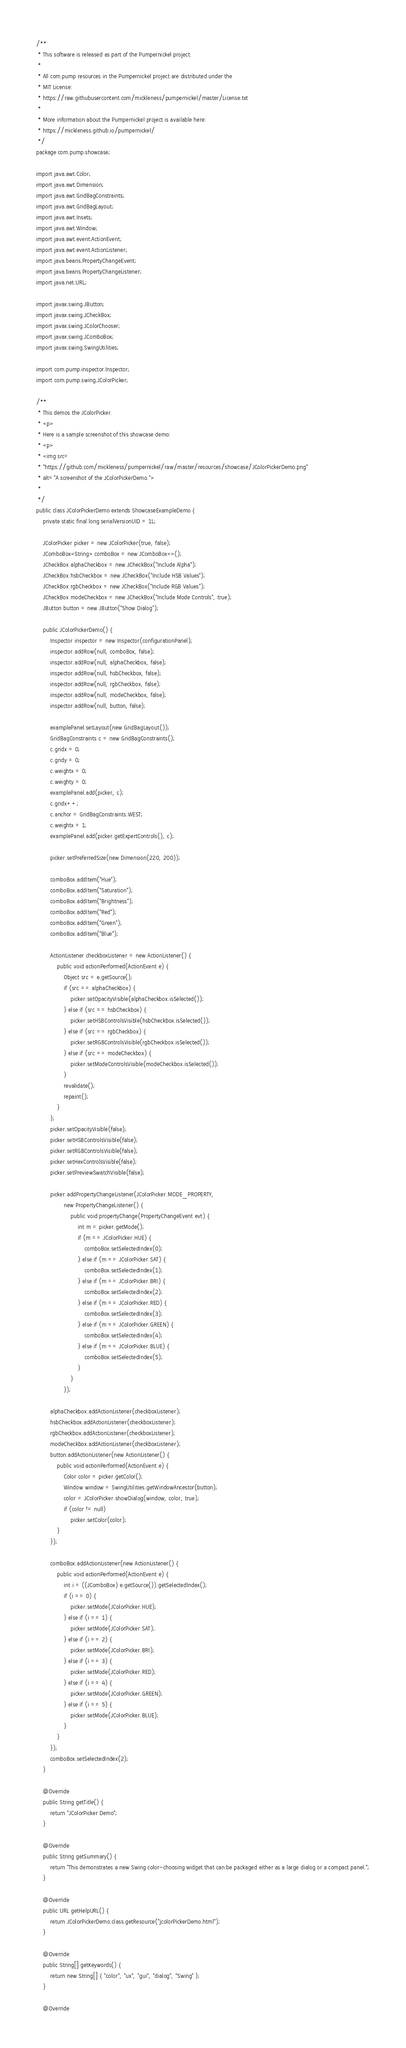Convert code to text. <code><loc_0><loc_0><loc_500><loc_500><_Java_>/**
 * This software is released as part of the Pumpernickel project.
 * 
 * All com.pump resources in the Pumpernickel project are distributed under the
 * MIT License:
 * https://raw.githubusercontent.com/mickleness/pumpernickel/master/License.txt
 * 
 * More information about the Pumpernickel project is available here:
 * https://mickleness.github.io/pumpernickel/
 */
package com.pump.showcase;

import java.awt.Color;
import java.awt.Dimension;
import java.awt.GridBagConstraints;
import java.awt.GridBagLayout;
import java.awt.Insets;
import java.awt.Window;
import java.awt.event.ActionEvent;
import java.awt.event.ActionListener;
import java.beans.PropertyChangeEvent;
import java.beans.PropertyChangeListener;
import java.net.URL;

import javax.swing.JButton;
import javax.swing.JCheckBox;
import javax.swing.JColorChooser;
import javax.swing.JComboBox;
import javax.swing.SwingUtilities;

import com.pump.inspector.Inspector;
import com.pump.swing.JColorPicker;

/**
 * This demos the JColorPicker.
 * <p>
 * Here is a sample screenshot of this showcase demo:
 * <p>
 * <img src=
 * "https://github.com/mickleness/pumpernickel/raw/master/resources/showcase/JColorPickerDemo.png"
 * alt="A screenshot of the JColorPickerDemo.">
 *
 */
public class JColorPickerDemo extends ShowcaseExampleDemo {
	private static final long serialVersionUID = 1L;

	JColorPicker picker = new JColorPicker(true, false);
	JComboBox<String> comboBox = new JComboBox<>();
	JCheckBox alphaCheckbox = new JCheckBox("Include Alpha");
	JCheckBox hsbCheckbox = new JCheckBox("Include HSB Values");
	JCheckBox rgbCheckbox = new JCheckBox("Include RGB Values");
	JCheckBox modeCheckbox = new JCheckBox("Include Mode Controls", true);
	JButton button = new JButton("Show Dialog");

	public JColorPickerDemo() {
		Inspector inspector = new Inspector(configurationPanel);
		inspector.addRow(null, comboBox, false);
		inspector.addRow(null, alphaCheckbox, false);
		inspector.addRow(null, hsbCheckbox, false);
		inspector.addRow(null, rgbCheckbox, false);
		inspector.addRow(null, modeCheckbox, false);
		inspector.addRow(null, button, false);

		examplePanel.setLayout(new GridBagLayout());
		GridBagConstraints c = new GridBagConstraints();
		c.gridx = 0;
		c.gridy = 0;
		c.weightx = 0;
		c.weighty = 0;
		examplePanel.add(picker, c);
		c.gridx++;
		c.anchor = GridBagConstraints.WEST;
		c.weightx = 1;
		examplePanel.add(picker.getExpertControls(), c);

		picker.setPreferredSize(new Dimension(220, 200));

		comboBox.addItem("Hue");
		comboBox.addItem("Saturation");
		comboBox.addItem("Brightness");
		comboBox.addItem("Red");
		comboBox.addItem("Green");
		comboBox.addItem("Blue");

		ActionListener checkboxListener = new ActionListener() {
			public void actionPerformed(ActionEvent e) {
				Object src = e.getSource();
				if (src == alphaCheckbox) {
					picker.setOpacityVisible(alphaCheckbox.isSelected());
				} else if (src == hsbCheckbox) {
					picker.setHSBControlsVisible(hsbCheckbox.isSelected());
				} else if (src == rgbCheckbox) {
					picker.setRGBControlsVisible(rgbCheckbox.isSelected());
				} else if (src == modeCheckbox) {
					picker.setModeControlsVisible(modeCheckbox.isSelected());
				}
				revalidate();
				repaint();
			}
		};
		picker.setOpacityVisible(false);
		picker.setHSBControlsVisible(false);
		picker.setRGBControlsVisible(false);
		picker.setHexControlsVisible(false);
		picker.setPreviewSwatchVisible(false);

		picker.addPropertyChangeListener(JColorPicker.MODE_PROPERTY,
				new PropertyChangeListener() {
					public void propertyChange(PropertyChangeEvent evt) {
						int m = picker.getMode();
						if (m == JColorPicker.HUE) {
							comboBox.setSelectedIndex(0);
						} else if (m == JColorPicker.SAT) {
							comboBox.setSelectedIndex(1);
						} else if (m == JColorPicker.BRI) {
							comboBox.setSelectedIndex(2);
						} else if (m == JColorPicker.RED) {
							comboBox.setSelectedIndex(3);
						} else if (m == JColorPicker.GREEN) {
							comboBox.setSelectedIndex(4);
						} else if (m == JColorPicker.BLUE) {
							comboBox.setSelectedIndex(5);
						}
					}
				});

		alphaCheckbox.addActionListener(checkboxListener);
		hsbCheckbox.addActionListener(checkboxListener);
		rgbCheckbox.addActionListener(checkboxListener);
		modeCheckbox.addActionListener(checkboxListener);
		button.addActionListener(new ActionListener() {
			public void actionPerformed(ActionEvent e) {
				Color color = picker.getColor();
				Window window = SwingUtilities.getWindowAncestor(button);
				color = JColorPicker.showDialog(window, color, true);
				if (color != null)
					picker.setColor(color);
			}
		});

		comboBox.addActionListener(new ActionListener() {
			public void actionPerformed(ActionEvent e) {
				int i = ((JComboBox) e.getSource()).getSelectedIndex();
				if (i == 0) {
					picker.setMode(JColorPicker.HUE);
				} else if (i == 1) {
					picker.setMode(JColorPicker.SAT);
				} else if (i == 2) {
					picker.setMode(JColorPicker.BRI);
				} else if (i == 3) {
					picker.setMode(JColorPicker.RED);
				} else if (i == 4) {
					picker.setMode(JColorPicker.GREEN);
				} else if (i == 5) {
					picker.setMode(JColorPicker.BLUE);
				}
			}
		});
		comboBox.setSelectedIndex(2);
	}

	@Override
	public String getTitle() {
		return "JColorPicker Demo";
	}

	@Override
	public String getSummary() {
		return "This demonstrates a new Swing color-choosing widget that can be packaged either as a large dialog or a compact panel.";
	}

	@Override
	public URL getHelpURL() {
		return JColorPickerDemo.class.getResource("jcolorPickerDemo.html");
	}

	@Override
	public String[] getKeywords() {
		return new String[] { "color", "ux", "gui", "dialog", "Swing" };
	}

	@Override</code> 